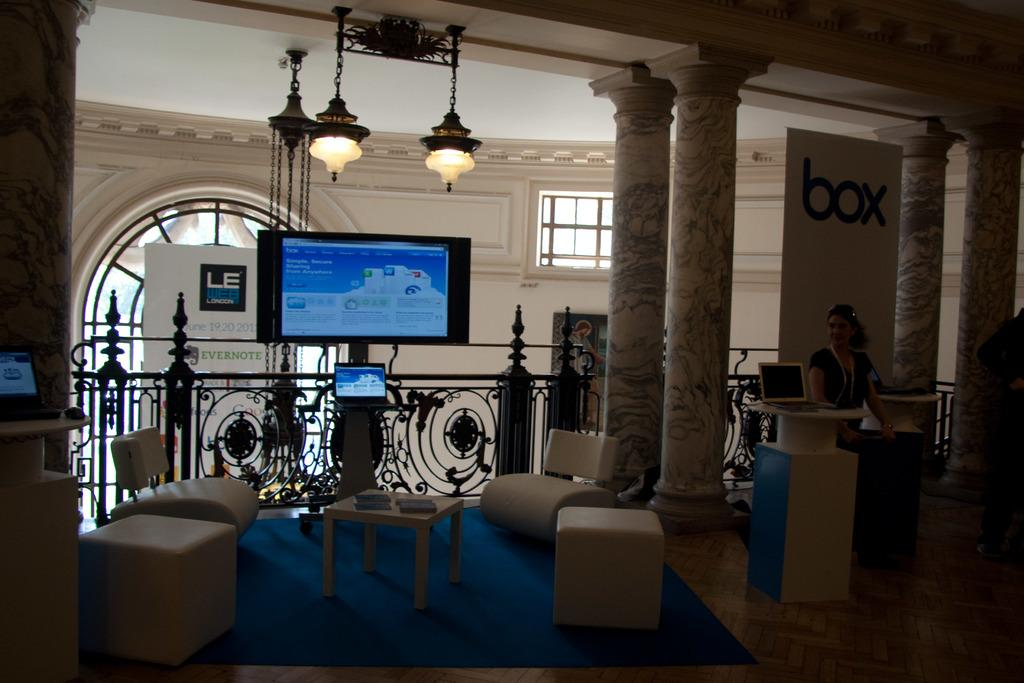Who is present in the image? There is a woman in the image. What is the woman wearing? The woman is wearing clothes. What is the woman doing in the image? The woman is sitting. What type of furniture is present in the image? There is a sofa and a table in the image. What type of flooring is present in the image? There is a carpet in the image. What type of surface is present in the image? There is a wooden surface in the image. What type of system is present in the image? The image contains a system, but it is not specified what kind. What type of screen is present in the image? The image contains a screen, but it is not specified what kind. What type of banner is present in the image? The image contains a banner, but it is not specified what kind. What type of fence is present in the image? The image contains a fence, but it is not specified what kind. What type of light is present in the image? The image contains a light, but it is not specified what kind. What type of window is present in the image? The image contains a window, but it is not specified what kind. What type of pillars are present in the image? The image contains pillars, but it is not specified what kind. How many crows are perched on the pillars in the image? There are no crows present in the image. What type of treatment is being administered to the woman in the image? There is no treatment being administered to the woman in the image. What type of bat is flying near the window in the image? There are no bats present in the image. 